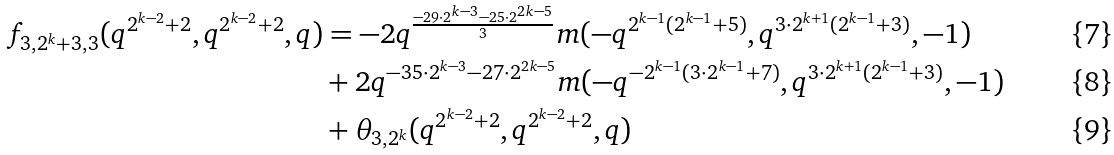Convert formula to latex. <formula><loc_0><loc_0><loc_500><loc_500>f _ { 3 , 2 ^ { k } + 3 , 3 } ( q ^ { 2 ^ { k - 2 } + 2 } , q ^ { 2 ^ { k - 2 } + 2 } , q ) & = - 2 q ^ { \frac { - 2 9 \cdot 2 ^ { k - 3 } - 2 5 \cdot 2 ^ { 2 k - 5 } } { 3 } } m ( - q ^ { 2 ^ { k - 1 } ( 2 ^ { k - 1 } + 5 ) } , q ^ { 3 \cdot 2 ^ { k + 1 } ( 2 ^ { k - 1 } + 3 ) } , - 1 ) \\ & + 2 q ^ { - 3 5 \cdot 2 ^ { k - 3 } - 2 7 \cdot 2 ^ { 2 k - 5 } } m ( - q ^ { - 2 ^ { k - 1 } ( 3 \cdot 2 ^ { k - 1 } + 7 ) } , q ^ { 3 \cdot 2 ^ { k + 1 } ( 2 ^ { k - 1 } + 3 ) } , - 1 ) \\ & + \theta _ { 3 , 2 ^ { k } } ( q ^ { 2 ^ { k - 2 } + 2 } , q ^ { 2 ^ { k - 2 } + 2 } , q )</formula> 